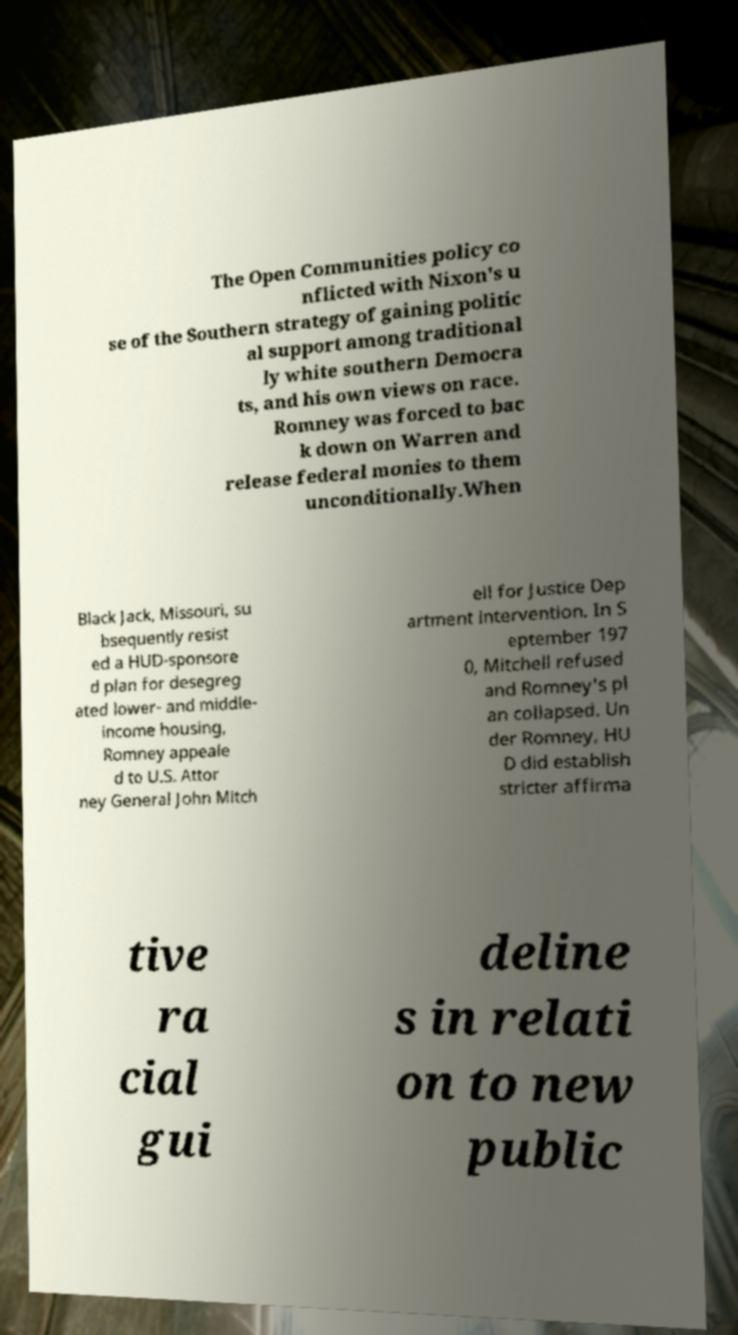What messages or text are displayed in this image? I need them in a readable, typed format. The Open Communities policy co nflicted with Nixon's u se of the Southern strategy of gaining politic al support among traditional ly white southern Democra ts, and his own views on race. Romney was forced to bac k down on Warren and release federal monies to them unconditionally.When Black Jack, Missouri, su bsequently resist ed a HUD-sponsore d plan for desegreg ated lower- and middle- income housing, Romney appeale d to U.S. Attor ney General John Mitch ell for Justice Dep artment intervention. In S eptember 197 0, Mitchell refused and Romney's pl an collapsed. Un der Romney, HU D did establish stricter affirma tive ra cial gui deline s in relati on to new public 